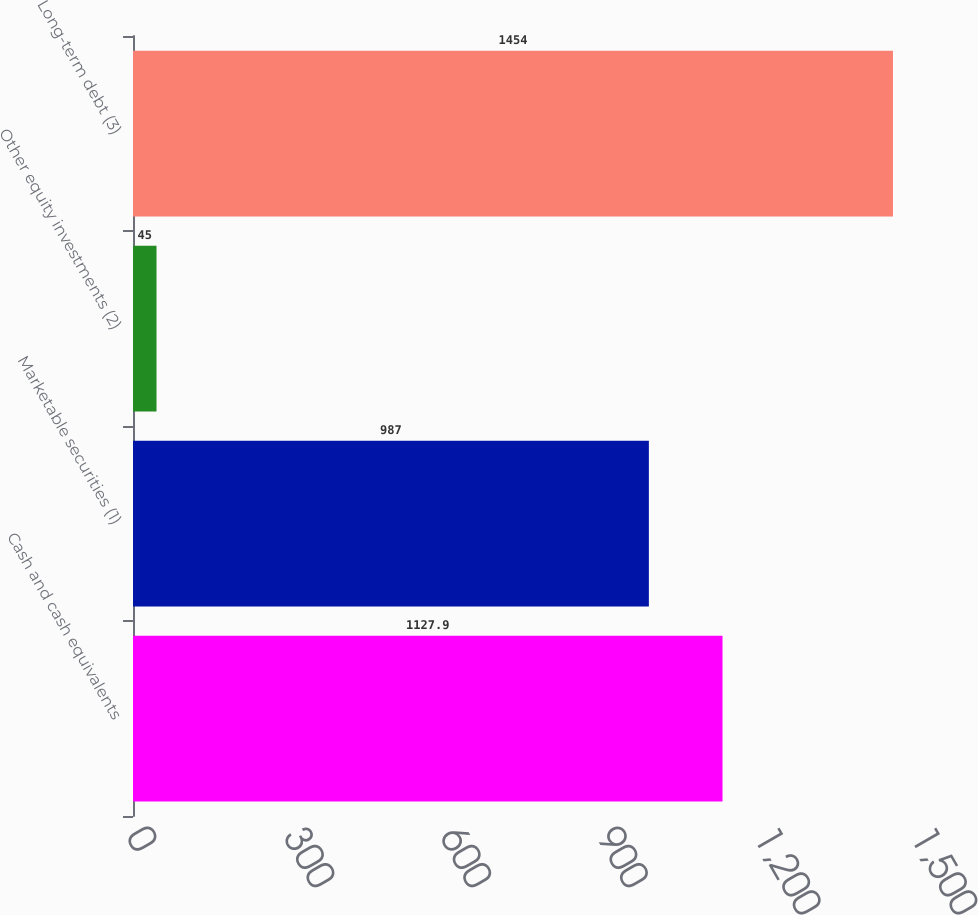<chart> <loc_0><loc_0><loc_500><loc_500><bar_chart><fcel>Cash and cash equivalents<fcel>Marketable securities (1)<fcel>Other equity investments (2)<fcel>Long-term debt (3)<nl><fcel>1127.9<fcel>987<fcel>45<fcel>1454<nl></chart> 